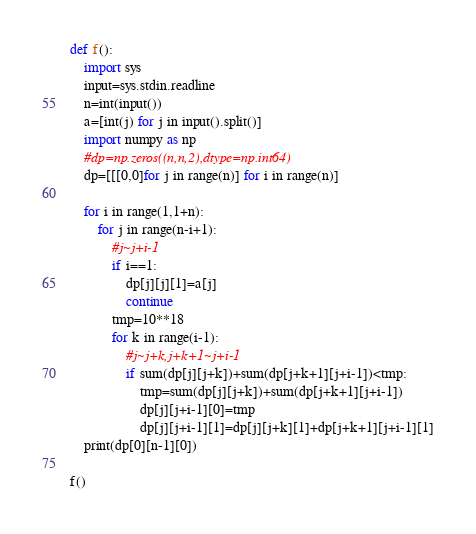Convert code to text. <code><loc_0><loc_0><loc_500><loc_500><_Python_>def f():
    import sys
    input=sys.stdin.readline
    n=int(input())
    a=[int(j) for j in input().split()]
    import numpy as np
    #dp=np.zeros((n,n,2),dtype=np.int64)
    dp=[[[0,0]for j in range(n)] for i in range(n)]

    for i in range(1,1+n):
        for j in range(n-i+1):
            #j~j+i-1
            if i==1:
                dp[j][j][1]=a[j]
                continue
            tmp=10**18
            for k in range(i-1):
                #j~j+k,j+k+1~j+i-1
                if sum(dp[j][j+k])+sum(dp[j+k+1][j+i-1])<tmp:
                    tmp=sum(dp[j][j+k])+sum(dp[j+k+1][j+i-1])
                    dp[j][j+i-1][0]=tmp
                    dp[j][j+i-1][1]=dp[j][j+k][1]+dp[j+k+1][j+i-1][1]
    print(dp[0][n-1][0])

f()</code> 